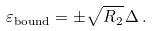Convert formula to latex. <formula><loc_0><loc_0><loc_500><loc_500>\varepsilon _ { \text {bound} } = \pm \sqrt { R _ { 2 } } \, \Delta \, .</formula> 